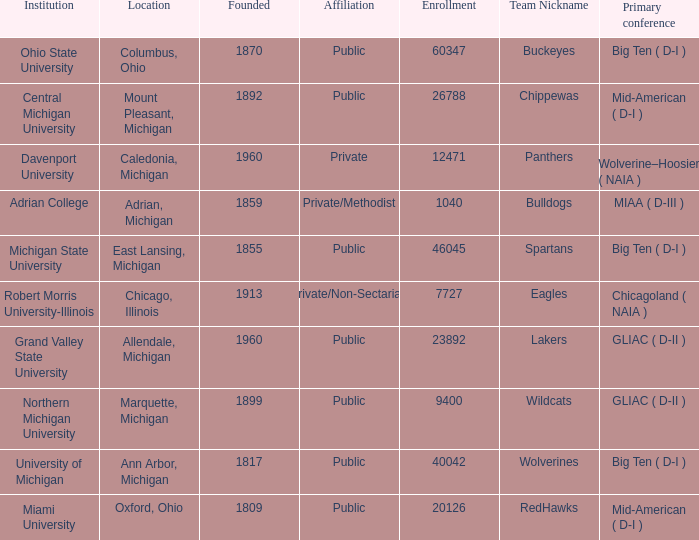Where is Robert Morris University-Illinois held? Chicago, Illinois. 